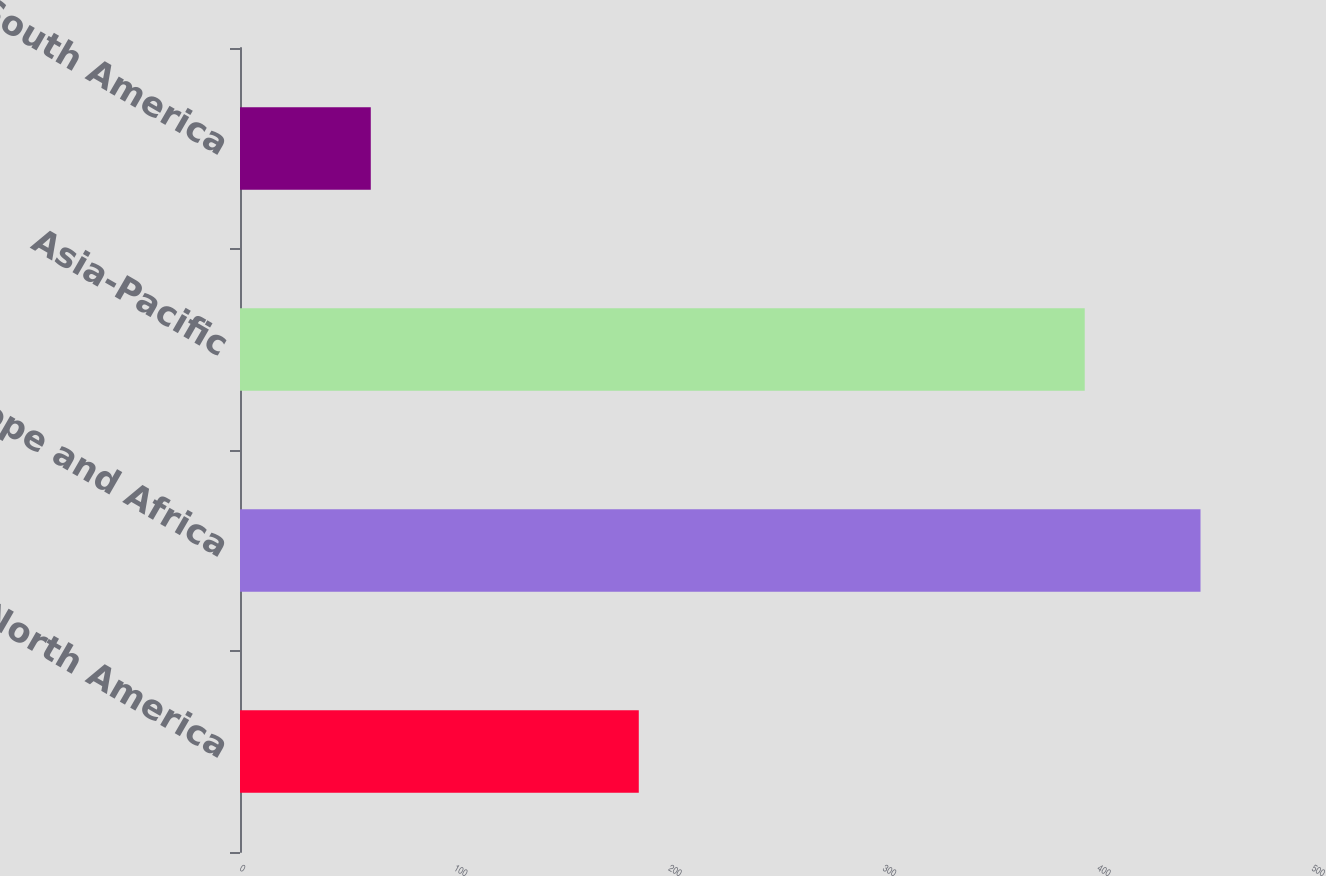Convert chart. <chart><loc_0><loc_0><loc_500><loc_500><bar_chart><fcel>North America<fcel>Europe and Africa<fcel>Asia-Pacific<fcel>South America<nl><fcel>186<fcel>448<fcel>394<fcel>61<nl></chart> 